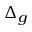<formula> <loc_0><loc_0><loc_500><loc_500>\Delta _ { g }</formula> 